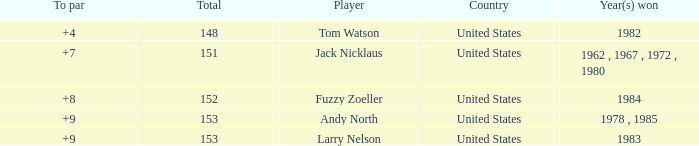What is the Total of the Player with a To par of 4? 1.0. 